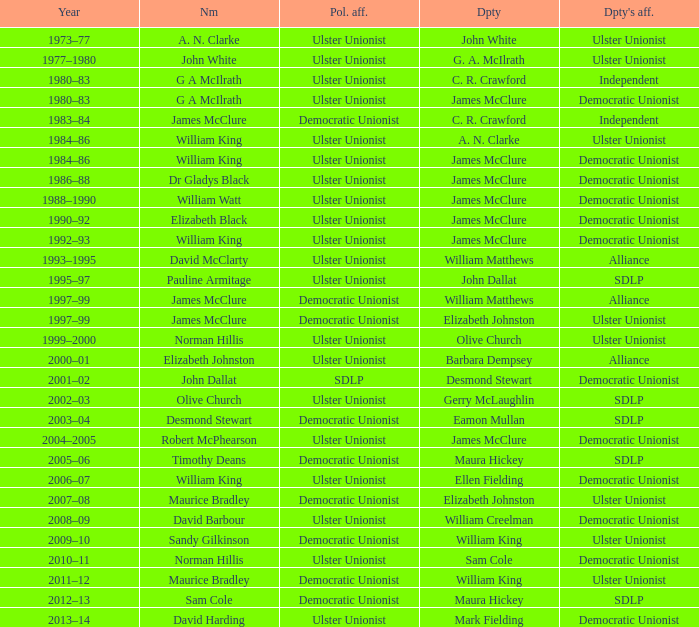What is the Political affiliation of deputy john dallat? Ulster Unionist. 